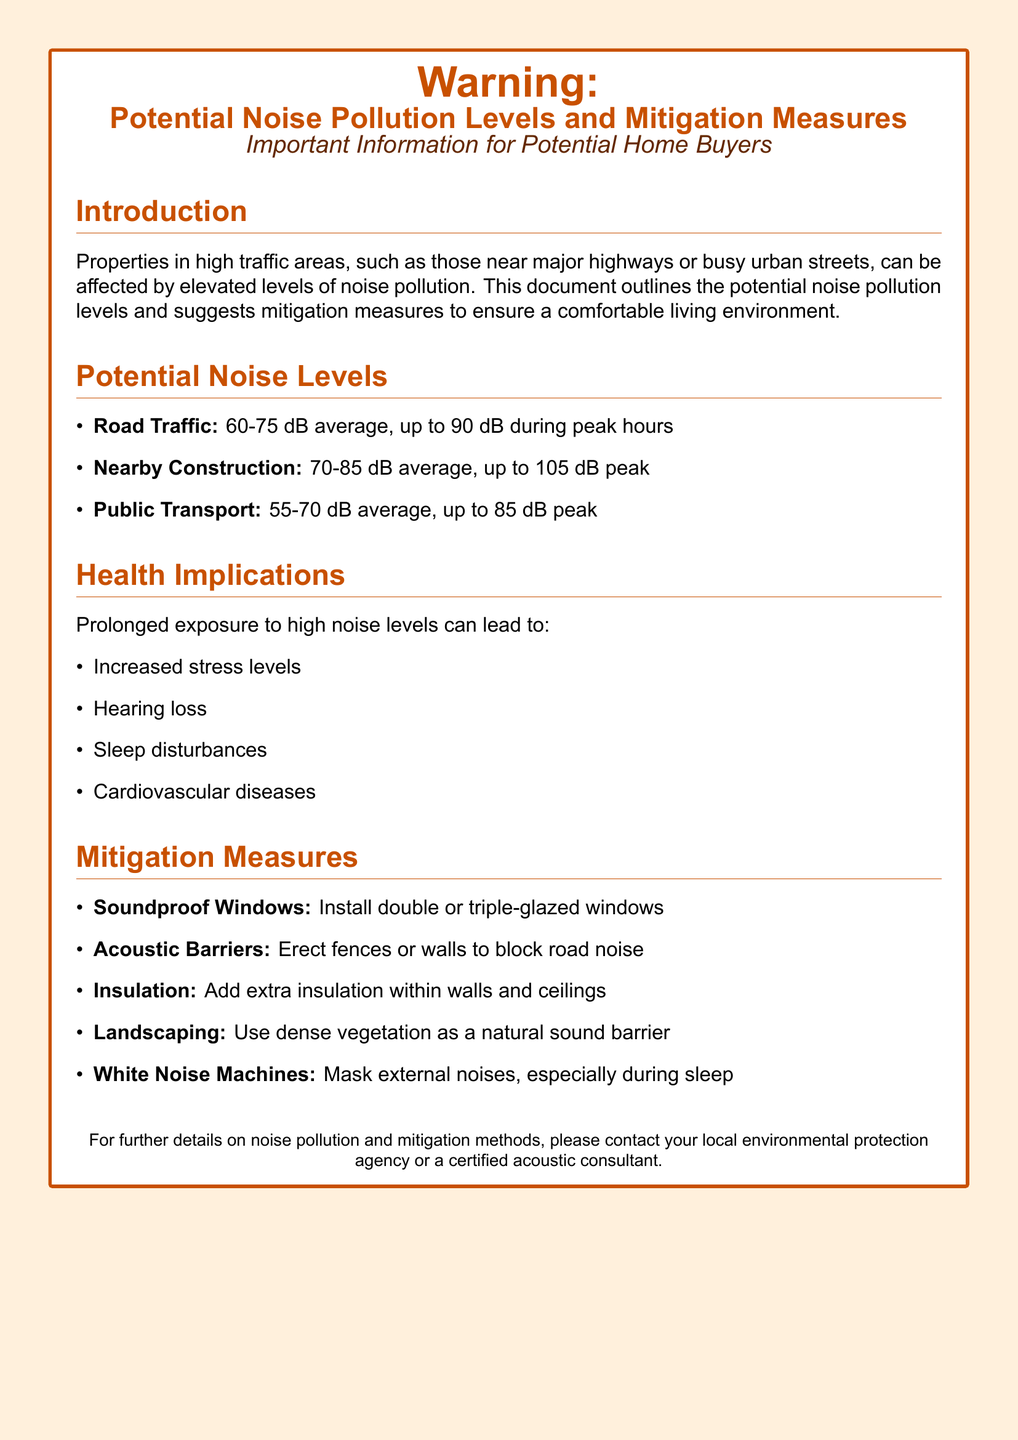What is the average noise level from road traffic? The document states that the average noise level from road traffic is between 60-75 dB.
Answer: 60-75 dB What peak noise level can be expected during nearby construction? According to the document, the peak noise level during nearby construction can reach up to 105 dB.
Answer: 105 dB What health issue is associated with high noise levels? The document lists several health implications, one being increased stress levels.
Answer: Increased stress levels What mitigation measure involves using vegetation? The document mentions landscaping as a mitigation measure that uses dense vegetation.
Answer: Landscaping What is the range of average noise levels for public transport? The average noise levels for public transport are stated in the document as 55-70 dB.
Answer: 55-70 dB What type of window installation is recommended for noise reduction? The document recommends installing double or triple-glazed windows for soundproofing.
Answer: Double or triple-glazed windows How can insulation help in high traffic areas? The document indicates that adding extra insulation within walls and ceilings is a mitigation measure.
Answer: Extra insulation What is the purpose of white noise machines? According to the document, white noise machines are used to mask external noises, especially during sleep.
Answer: Mask external noises What common cardiovascular condition can prolonged noise exposure lead to? The document identifies cardiovascular diseases as a potential health implication of prolonged noise exposure.
Answer: Cardiovascular diseases 